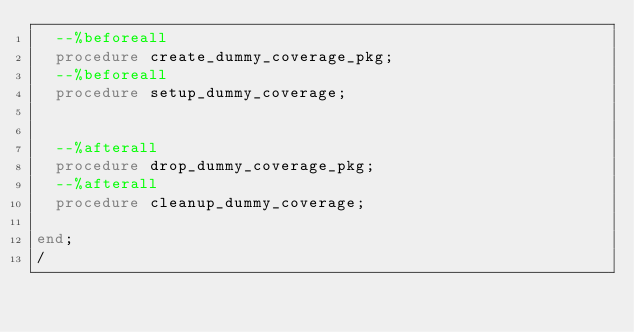Convert code to text. <code><loc_0><loc_0><loc_500><loc_500><_SQL_>  --%beforeall
  procedure create_dummy_coverage_pkg;
  --%beforeall
  procedure setup_dummy_coverage;


  --%afterall
  procedure drop_dummy_coverage_pkg;
  --%afterall
  procedure cleanup_dummy_coverage;

end;
/
</code> 